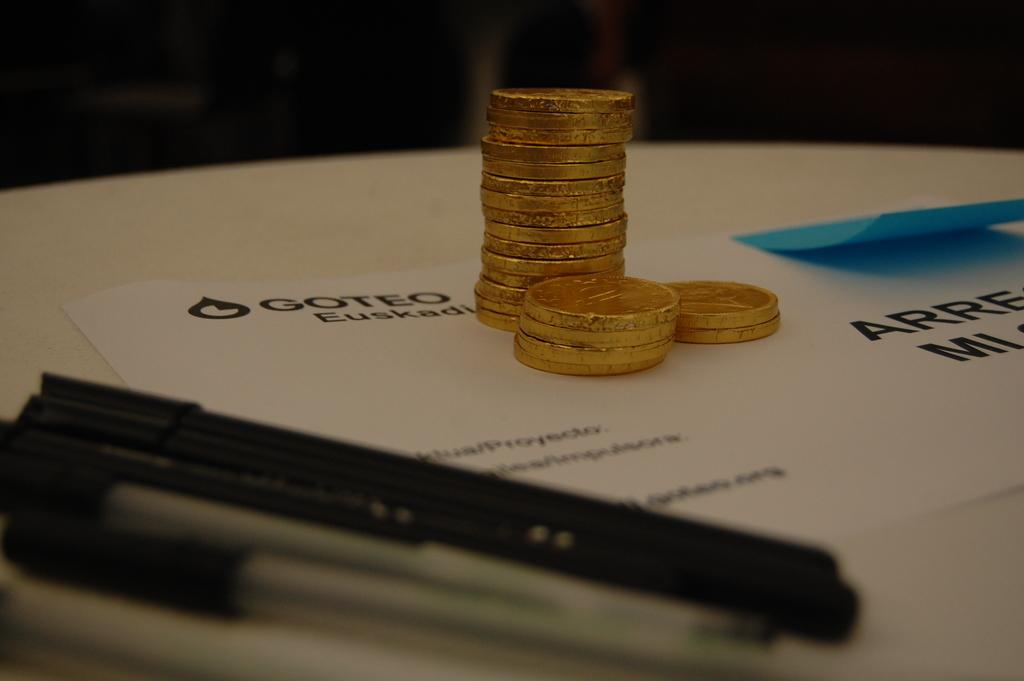Provide a one-sentence caption for the provided image. Some coins and ink pens sit on a piece of paper labeled "Goteo.". 